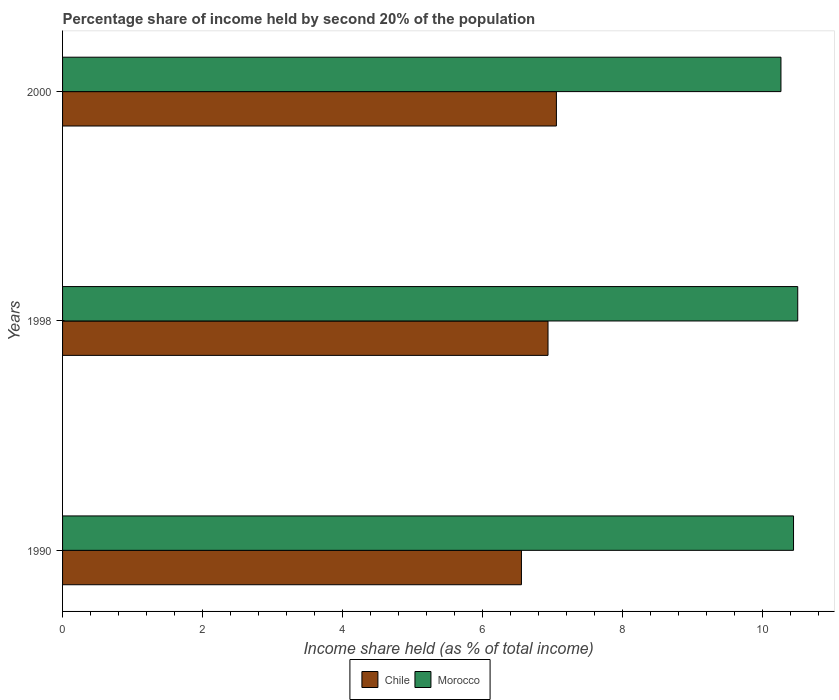How many different coloured bars are there?
Make the answer very short. 2. Are the number of bars on each tick of the Y-axis equal?
Give a very brief answer. Yes. How many bars are there on the 2nd tick from the top?
Offer a terse response. 2. In how many cases, is the number of bars for a given year not equal to the number of legend labels?
Make the answer very short. 0. What is the share of income held by second 20% of the population in Chile in 2000?
Provide a succinct answer. 7.06. Across all years, what is the maximum share of income held by second 20% of the population in Chile?
Your response must be concise. 7.06. Across all years, what is the minimum share of income held by second 20% of the population in Chile?
Make the answer very short. 6.56. In which year was the share of income held by second 20% of the population in Morocco maximum?
Provide a short and direct response. 1998. What is the total share of income held by second 20% of the population in Morocco in the graph?
Make the answer very short. 31.23. What is the difference between the share of income held by second 20% of the population in Chile in 1990 and that in 1998?
Offer a terse response. -0.38. What is the difference between the share of income held by second 20% of the population in Morocco in 1990 and the share of income held by second 20% of the population in Chile in 2000?
Provide a succinct answer. 3.39. What is the average share of income held by second 20% of the population in Chile per year?
Offer a terse response. 6.85. In the year 2000, what is the difference between the share of income held by second 20% of the population in Morocco and share of income held by second 20% of the population in Chile?
Provide a short and direct response. 3.21. In how many years, is the share of income held by second 20% of the population in Chile greater than 0.4 %?
Your response must be concise. 3. What is the ratio of the share of income held by second 20% of the population in Morocco in 1998 to that in 2000?
Offer a very short reply. 1.02. Is the share of income held by second 20% of the population in Chile in 1990 less than that in 2000?
Your answer should be compact. Yes. What is the difference between the highest and the second highest share of income held by second 20% of the population in Morocco?
Your response must be concise. 0.06. What is the difference between the highest and the lowest share of income held by second 20% of the population in Morocco?
Keep it short and to the point. 0.24. In how many years, is the share of income held by second 20% of the population in Chile greater than the average share of income held by second 20% of the population in Chile taken over all years?
Your response must be concise. 2. Is the sum of the share of income held by second 20% of the population in Chile in 1998 and 2000 greater than the maximum share of income held by second 20% of the population in Morocco across all years?
Your answer should be very brief. Yes. What does the 2nd bar from the top in 1990 represents?
Your answer should be compact. Chile. What does the 2nd bar from the bottom in 1990 represents?
Your answer should be very brief. Morocco. How many bars are there?
Your answer should be compact. 6. Are all the bars in the graph horizontal?
Make the answer very short. Yes. How many years are there in the graph?
Offer a terse response. 3. Does the graph contain any zero values?
Make the answer very short. No. What is the title of the graph?
Give a very brief answer. Percentage share of income held by second 20% of the population. Does "OECD members" appear as one of the legend labels in the graph?
Your response must be concise. No. What is the label or title of the X-axis?
Make the answer very short. Income share held (as % of total income). What is the Income share held (as % of total income) of Chile in 1990?
Make the answer very short. 6.56. What is the Income share held (as % of total income) in Morocco in 1990?
Provide a short and direct response. 10.45. What is the Income share held (as % of total income) in Chile in 1998?
Your response must be concise. 6.94. What is the Income share held (as % of total income) of Morocco in 1998?
Your answer should be compact. 10.51. What is the Income share held (as % of total income) in Chile in 2000?
Ensure brevity in your answer.  7.06. What is the Income share held (as % of total income) in Morocco in 2000?
Make the answer very short. 10.27. Across all years, what is the maximum Income share held (as % of total income) in Chile?
Your response must be concise. 7.06. Across all years, what is the maximum Income share held (as % of total income) in Morocco?
Give a very brief answer. 10.51. Across all years, what is the minimum Income share held (as % of total income) in Chile?
Ensure brevity in your answer.  6.56. Across all years, what is the minimum Income share held (as % of total income) of Morocco?
Your answer should be compact. 10.27. What is the total Income share held (as % of total income) in Chile in the graph?
Ensure brevity in your answer.  20.56. What is the total Income share held (as % of total income) in Morocco in the graph?
Your answer should be compact. 31.23. What is the difference between the Income share held (as % of total income) of Chile in 1990 and that in 1998?
Your answer should be compact. -0.38. What is the difference between the Income share held (as % of total income) of Morocco in 1990 and that in 1998?
Provide a short and direct response. -0.06. What is the difference between the Income share held (as % of total income) in Morocco in 1990 and that in 2000?
Your answer should be very brief. 0.18. What is the difference between the Income share held (as % of total income) in Chile in 1998 and that in 2000?
Your response must be concise. -0.12. What is the difference between the Income share held (as % of total income) in Morocco in 1998 and that in 2000?
Provide a succinct answer. 0.24. What is the difference between the Income share held (as % of total income) in Chile in 1990 and the Income share held (as % of total income) in Morocco in 1998?
Your answer should be compact. -3.95. What is the difference between the Income share held (as % of total income) in Chile in 1990 and the Income share held (as % of total income) in Morocco in 2000?
Make the answer very short. -3.71. What is the difference between the Income share held (as % of total income) in Chile in 1998 and the Income share held (as % of total income) in Morocco in 2000?
Provide a short and direct response. -3.33. What is the average Income share held (as % of total income) of Chile per year?
Your answer should be compact. 6.85. What is the average Income share held (as % of total income) in Morocco per year?
Make the answer very short. 10.41. In the year 1990, what is the difference between the Income share held (as % of total income) of Chile and Income share held (as % of total income) of Morocco?
Keep it short and to the point. -3.89. In the year 1998, what is the difference between the Income share held (as % of total income) in Chile and Income share held (as % of total income) in Morocco?
Offer a terse response. -3.57. In the year 2000, what is the difference between the Income share held (as % of total income) in Chile and Income share held (as % of total income) in Morocco?
Provide a short and direct response. -3.21. What is the ratio of the Income share held (as % of total income) of Chile in 1990 to that in 1998?
Your answer should be very brief. 0.95. What is the ratio of the Income share held (as % of total income) of Chile in 1990 to that in 2000?
Make the answer very short. 0.93. What is the ratio of the Income share held (as % of total income) in Morocco in 1990 to that in 2000?
Ensure brevity in your answer.  1.02. What is the ratio of the Income share held (as % of total income) in Chile in 1998 to that in 2000?
Offer a very short reply. 0.98. What is the ratio of the Income share held (as % of total income) in Morocco in 1998 to that in 2000?
Make the answer very short. 1.02. What is the difference between the highest and the second highest Income share held (as % of total income) of Chile?
Keep it short and to the point. 0.12. What is the difference between the highest and the second highest Income share held (as % of total income) in Morocco?
Your response must be concise. 0.06. What is the difference between the highest and the lowest Income share held (as % of total income) of Morocco?
Your answer should be compact. 0.24. 